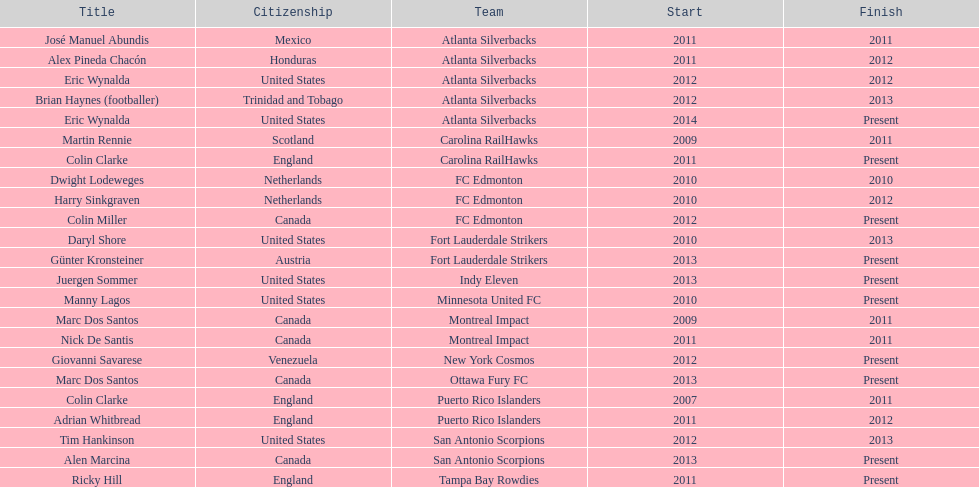Marc dos santos started as coach the same year as what other coach? Martin Rennie. 